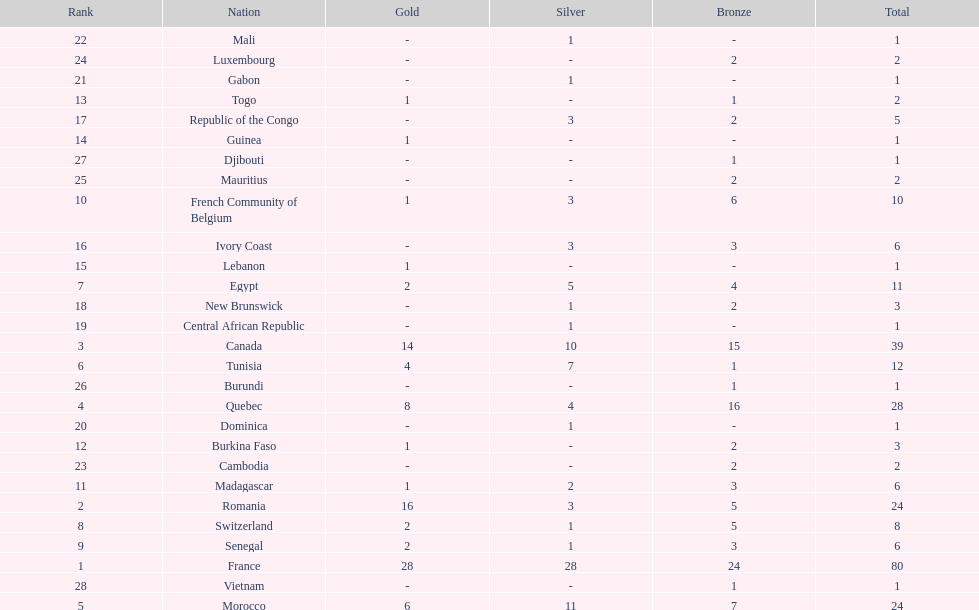What was the total medal count of switzerland? 8. 